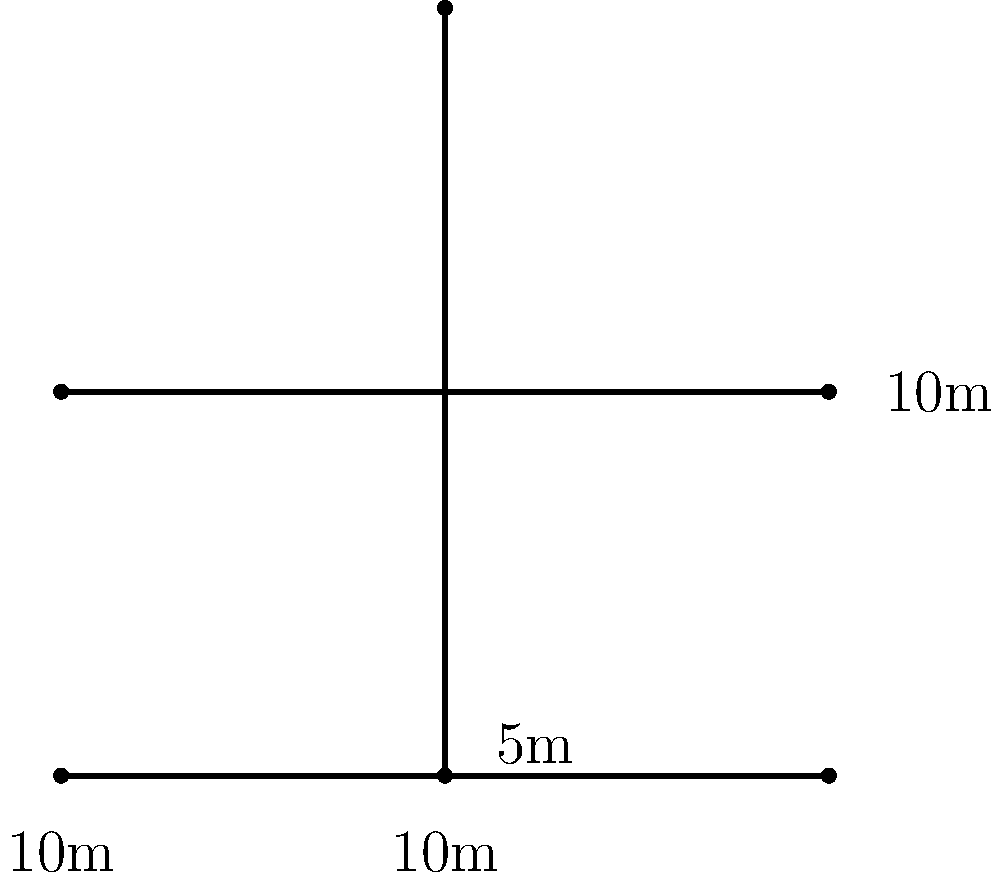As part of a new urban accessibility initiative, you're tasked with implementing tactile paving at a complex intersection. The diagram shows a series of interconnected pedestrian crossings. Each crossing is 10 meters long and requires a 0.6-meter wide strip of tactile paving on both sides. Calculate the total area of tactile paving needed for this intersection, taking into account that overlapping areas should not be counted twice. Let's approach this step-by-step:

1) First, let's calculate the length of all the crossings:
   - There are three 10-meter crossings
   - Total length = $10m + 10m + 10m = 30m$

2) Each crossing needs tactile paving on both sides, so we double the total length:
   - Length for paving = $30m \times 2 = 60m$

3) The width of each tactile paving strip is 0.6 meters, so we calculate the area:
   - Area = length × width
   - Area = $60m \times 0.6m = 36m^2$

4) However, we need to account for the overlapping areas at the intersection points:
   - There are 4 intersection points
   - Each intersection point has an overlap of $0.6m \times 0.6m = 0.36m^2$
   - Total overlap = $4 \times 0.36m^2 = 1.44m^2$

5) We subtract the overlapping area from our initial calculation:
   - Final area = $36m^2 - 1.44m^2 = 34.56m^2$

Therefore, the total area of tactile paving needed is 34.56 square meters.
Answer: $34.56m^2$ 